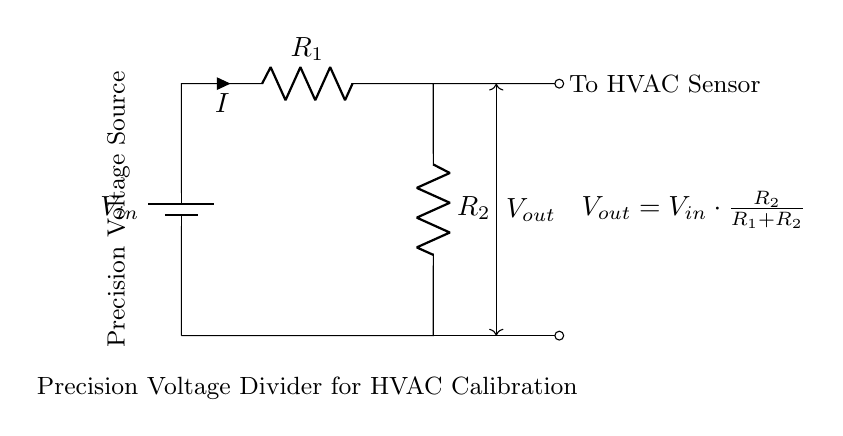What is the input voltage labeled as? The input voltage in the circuit is labeled as V_in, which represents the voltage supplied to the voltage divider.
Answer: V_in What are the values of the resistors in the circuit? The circuit labels resistors as R_1 and R_2, but their specific numerical values are not provided in the visual diagram, indicating their role rather than their magnitude.
Answer: R_1 and R_2 What is the output voltage formula provided in the diagram? The output voltage formula is given as V_out = V_in * (R_2 / (R_1 + R_2)), which describes how the output voltage relates to the input voltage and the resistor values in the voltage divider.
Answer: V_out = V_in * (R_2 / (R_1 + R_2)) What type of current flows through the resistors? The circuit shows a conventional flow of current denoted as I, indicating that direct current (DC) is used in this voltage divider circuit.
Answer: DC What is the purpose of the precision voltage source in this circuit? The precision voltage source serves to provide a stable and accurate input voltage for the calibration of HVAC sensors, ensuring consistent readings.
Answer: Calibration How does the choice of R_1 and R_2 affect V_out? The values of R_1 and R_2 directly influence V_out based on their ratio; a larger R_2 relative to R_1 results in a higher output voltage, while a smaller R_2 will yield a lower output voltage.
Answer: R_1 and R_2 ratio What is the expected effect on V_out if R_1 is increased? Increasing R_1 would decrease V_out because the proportion of R_1 to the total resistance (R_1 + R_2) would be larger, reducing the output voltage proportionally.
Answer: Decrease 